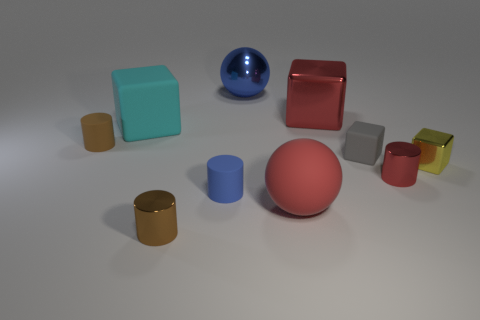There is another ball that is the same size as the metal sphere; what is it made of?
Your answer should be compact. Rubber. Is there another ball of the same size as the red rubber ball?
Your answer should be very brief. Yes. There is a blue object that is behind the cyan matte cube; is its size the same as the brown rubber object?
Keep it short and to the point. No. There is a metal thing that is both in front of the cyan object and behind the tiny red cylinder; what shape is it?
Your response must be concise. Cube. Is the number of metallic objects in front of the large cyan object greater than the number of tiny gray matte cubes?
Provide a succinct answer. Yes. What is the size of the yellow cube that is made of the same material as the blue sphere?
Provide a short and direct response. Small. How many other big balls are the same color as the big metallic sphere?
Your answer should be very brief. 0. There is a cylinder in front of the red ball; is its color the same as the matte ball?
Offer a terse response. No. Are there an equal number of big red balls on the right side of the large red metal thing and red rubber spheres that are behind the small red metal cylinder?
Provide a short and direct response. Yes. There is a tiny rubber object that is on the left side of the brown metallic cylinder; what is its color?
Your answer should be very brief. Brown. 